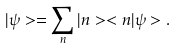Convert formula to latex. <formula><loc_0><loc_0><loc_500><loc_500>| \psi > = \sum _ { n } | n > < n | \psi > .</formula> 